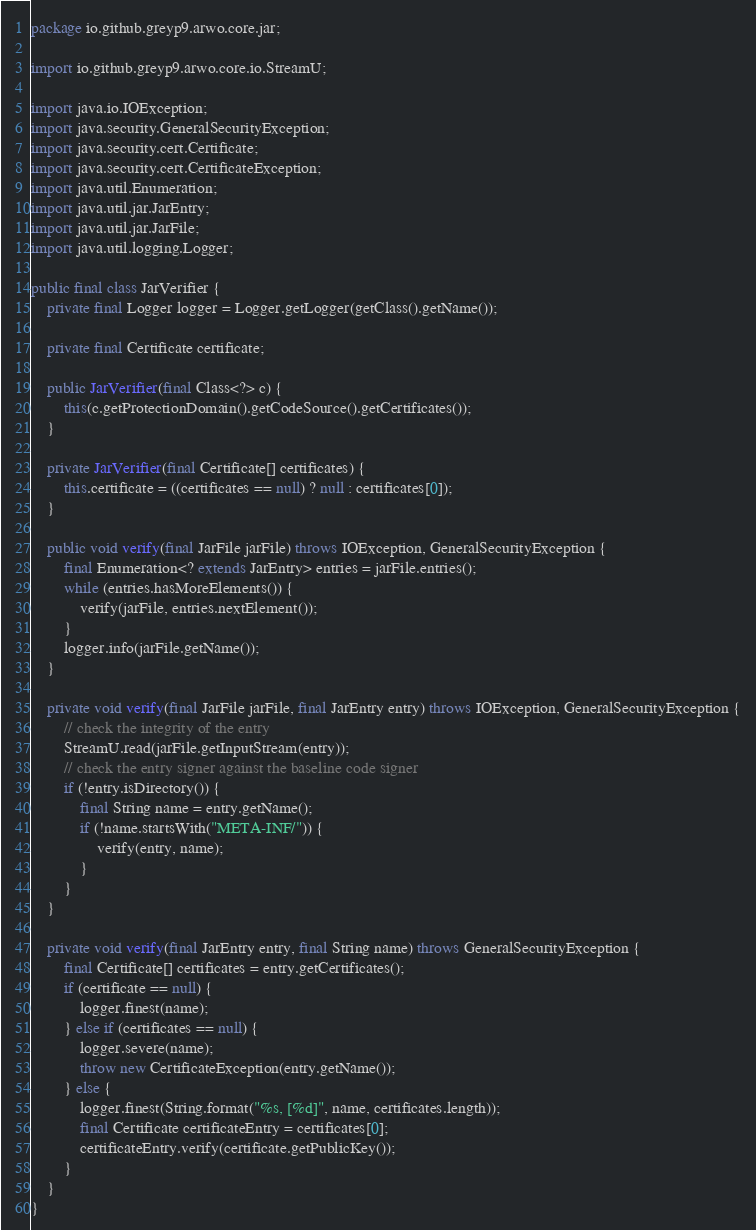<code> <loc_0><loc_0><loc_500><loc_500><_Java_>package io.github.greyp9.arwo.core.jar;

import io.github.greyp9.arwo.core.io.StreamU;

import java.io.IOException;
import java.security.GeneralSecurityException;
import java.security.cert.Certificate;
import java.security.cert.CertificateException;
import java.util.Enumeration;
import java.util.jar.JarEntry;
import java.util.jar.JarFile;
import java.util.logging.Logger;

public final class JarVerifier {
    private final Logger logger = Logger.getLogger(getClass().getName());

    private final Certificate certificate;

    public JarVerifier(final Class<?> c) {
        this(c.getProtectionDomain().getCodeSource().getCertificates());
    }

    private JarVerifier(final Certificate[] certificates) {
        this.certificate = ((certificates == null) ? null : certificates[0]);
    }

    public void verify(final JarFile jarFile) throws IOException, GeneralSecurityException {
        final Enumeration<? extends JarEntry> entries = jarFile.entries();
        while (entries.hasMoreElements()) {
            verify(jarFile, entries.nextElement());
        }
        logger.info(jarFile.getName());
    }

    private void verify(final JarFile jarFile, final JarEntry entry) throws IOException, GeneralSecurityException {
        // check the integrity of the entry
        StreamU.read(jarFile.getInputStream(entry));
        // check the entry signer against the baseline code signer
        if (!entry.isDirectory()) {
            final String name = entry.getName();
            if (!name.startsWith("META-INF/")) {
                verify(entry, name);
            }
        }
    }

    private void verify(final JarEntry entry, final String name) throws GeneralSecurityException {
        final Certificate[] certificates = entry.getCertificates();
        if (certificate == null) {
            logger.finest(name);
        } else if (certificates == null) {
            logger.severe(name);
            throw new CertificateException(entry.getName());
        } else {
            logger.finest(String.format("%s, [%d]", name, certificates.length));
            final Certificate certificateEntry = certificates[0];
            certificateEntry.verify(certificate.getPublicKey());
        }
    }
}
</code> 